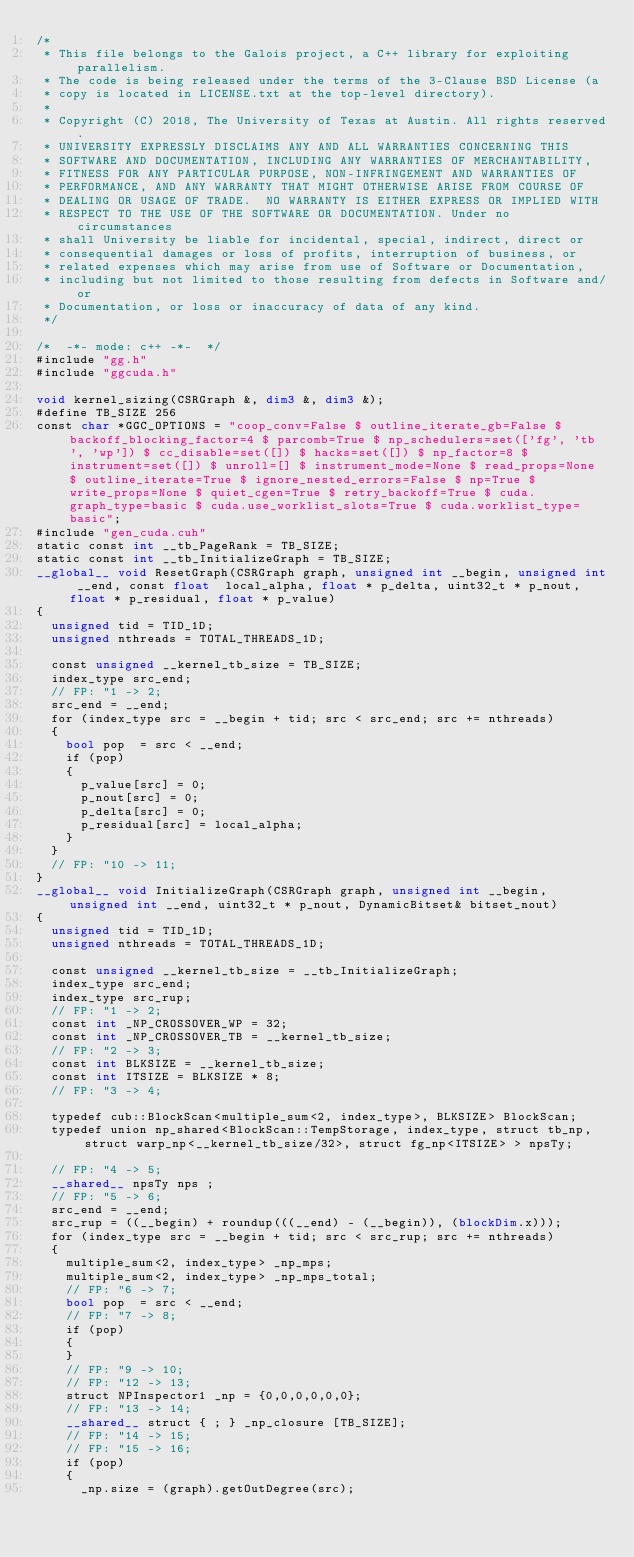<code> <loc_0><loc_0><loc_500><loc_500><_Cuda_>/*
 * This file belongs to the Galois project, a C++ library for exploiting parallelism.
 * The code is being released under the terms of the 3-Clause BSD License (a
 * copy is located in LICENSE.txt at the top-level directory).
 *
 * Copyright (C) 2018, The University of Texas at Austin. All rights reserved.
 * UNIVERSITY EXPRESSLY DISCLAIMS ANY AND ALL WARRANTIES CONCERNING THIS
 * SOFTWARE AND DOCUMENTATION, INCLUDING ANY WARRANTIES OF MERCHANTABILITY,
 * FITNESS FOR ANY PARTICULAR PURPOSE, NON-INFRINGEMENT AND WARRANTIES OF
 * PERFORMANCE, AND ANY WARRANTY THAT MIGHT OTHERWISE ARISE FROM COURSE OF
 * DEALING OR USAGE OF TRADE.  NO WARRANTY IS EITHER EXPRESS OR IMPLIED WITH
 * RESPECT TO THE USE OF THE SOFTWARE OR DOCUMENTATION. Under no circumstances
 * shall University be liable for incidental, special, indirect, direct or
 * consequential damages or loss of profits, interruption of business, or
 * related expenses which may arise from use of Software or Documentation,
 * including but not limited to those resulting from defects in Software and/or
 * Documentation, or loss or inaccuracy of data of any kind.
 */

/*  -*- mode: c++ -*-  */
#include "gg.h"
#include "ggcuda.h"

void kernel_sizing(CSRGraph &, dim3 &, dim3 &);
#define TB_SIZE 256
const char *GGC_OPTIONS = "coop_conv=False $ outline_iterate_gb=False $ backoff_blocking_factor=4 $ parcomb=True $ np_schedulers=set(['fg', 'tb', 'wp']) $ cc_disable=set([]) $ hacks=set([]) $ np_factor=8 $ instrument=set([]) $ unroll=[] $ instrument_mode=None $ read_props=None $ outline_iterate=True $ ignore_nested_errors=False $ np=True $ write_props=None $ quiet_cgen=True $ retry_backoff=True $ cuda.graph_type=basic $ cuda.use_worklist_slots=True $ cuda.worklist_type=basic";
#include "gen_cuda.cuh"
static const int __tb_PageRank = TB_SIZE;
static const int __tb_InitializeGraph = TB_SIZE;
__global__ void ResetGraph(CSRGraph graph, unsigned int __begin, unsigned int __end, const float  local_alpha, float * p_delta, uint32_t * p_nout, float * p_residual, float * p_value)
{
  unsigned tid = TID_1D;
  unsigned nthreads = TOTAL_THREADS_1D;

  const unsigned __kernel_tb_size = TB_SIZE;
  index_type src_end;
  // FP: "1 -> 2;
  src_end = __end;
  for (index_type src = __begin + tid; src < src_end; src += nthreads)
  {
    bool pop  = src < __end;
    if (pop)
    {
      p_value[src] = 0;
      p_nout[src] = 0;
      p_delta[src] = 0;
      p_residual[src] = local_alpha;
    }
  }
  // FP: "10 -> 11;
}
__global__ void InitializeGraph(CSRGraph graph, unsigned int __begin, unsigned int __end, uint32_t * p_nout, DynamicBitset& bitset_nout)
{
  unsigned tid = TID_1D;
  unsigned nthreads = TOTAL_THREADS_1D;

  const unsigned __kernel_tb_size = __tb_InitializeGraph;
  index_type src_end;
  index_type src_rup;
  // FP: "1 -> 2;
  const int _NP_CROSSOVER_WP = 32;
  const int _NP_CROSSOVER_TB = __kernel_tb_size;
  // FP: "2 -> 3;
  const int BLKSIZE = __kernel_tb_size;
  const int ITSIZE = BLKSIZE * 8;
  // FP: "3 -> 4;

  typedef cub::BlockScan<multiple_sum<2, index_type>, BLKSIZE> BlockScan;
  typedef union np_shared<BlockScan::TempStorage, index_type, struct tb_np, struct warp_np<__kernel_tb_size/32>, struct fg_np<ITSIZE> > npsTy;

  // FP: "4 -> 5;
  __shared__ npsTy nps ;
  // FP: "5 -> 6;
  src_end = __end;
  src_rup = ((__begin) + roundup(((__end) - (__begin)), (blockDim.x)));
  for (index_type src = __begin + tid; src < src_rup; src += nthreads)
  {
    multiple_sum<2, index_type> _np_mps;
    multiple_sum<2, index_type> _np_mps_total;
    // FP: "6 -> 7;
    bool pop  = src < __end;
    // FP: "7 -> 8;
    if (pop)
    {
    }
    // FP: "9 -> 10;
    // FP: "12 -> 13;
    struct NPInspector1 _np = {0,0,0,0,0,0};
    // FP: "13 -> 14;
    __shared__ struct { ; } _np_closure [TB_SIZE];
    // FP: "14 -> 15;
    // FP: "15 -> 16;
    if (pop)
    {
      _np.size = (graph).getOutDegree(src);</code> 